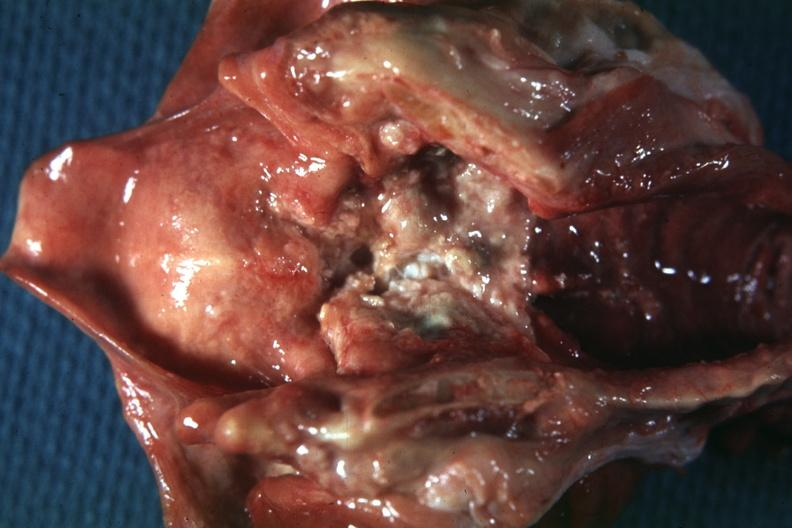what is present?
Answer the question using a single word or phrase. Squamous cell carcinoma 